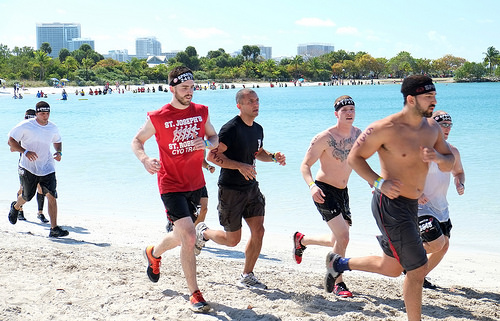<image>
Can you confirm if the red tshirt is next to the shoes? No. The red tshirt is not positioned next to the shoes. They are located in different areas of the scene. 